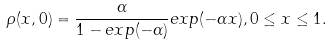Convert formula to latex. <formula><loc_0><loc_0><loc_500><loc_500>\rho ( x , 0 ) = \frac { \alpha } { 1 - e x p ( - \alpha ) } e x p ( - \alpha x ) , 0 \leq x \leq 1 .</formula> 